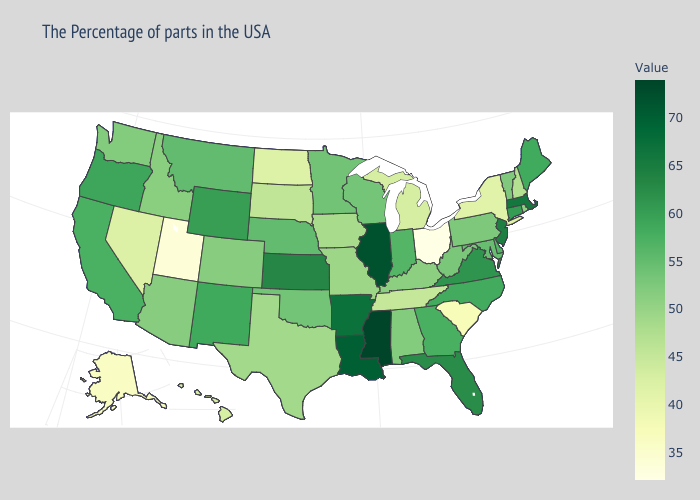Does Illinois have the lowest value in the USA?
Concise answer only. No. Among the states that border North Carolina , does Georgia have the lowest value?
Keep it brief. No. Does Kansas have a higher value than Illinois?
Give a very brief answer. No. 